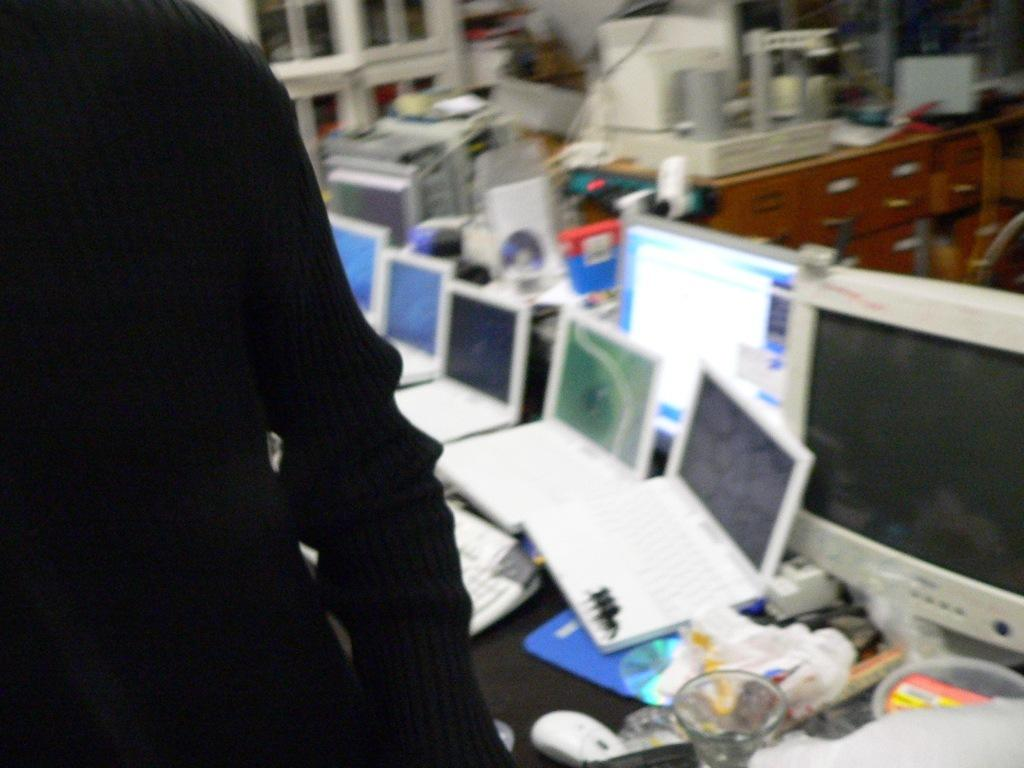What is located on the left side of the image? There is cloth on the left side of the image. What type of electronic devices can be seen in the image? There are laptops and a monitor in the image. What type of objects are made of glass in the image? There are glass objects in the image. What piece of furniture is present in the image? There is a desk in the image. Can you describe any other items in the image that are not specified in the facts? Unfortunately, the provided facts do not give any information about other items in the image. What type of joke is being told by the desk in the image? There is no joke being told by the desk in the image, as desks are inanimate objects and cannot tell jokes. 